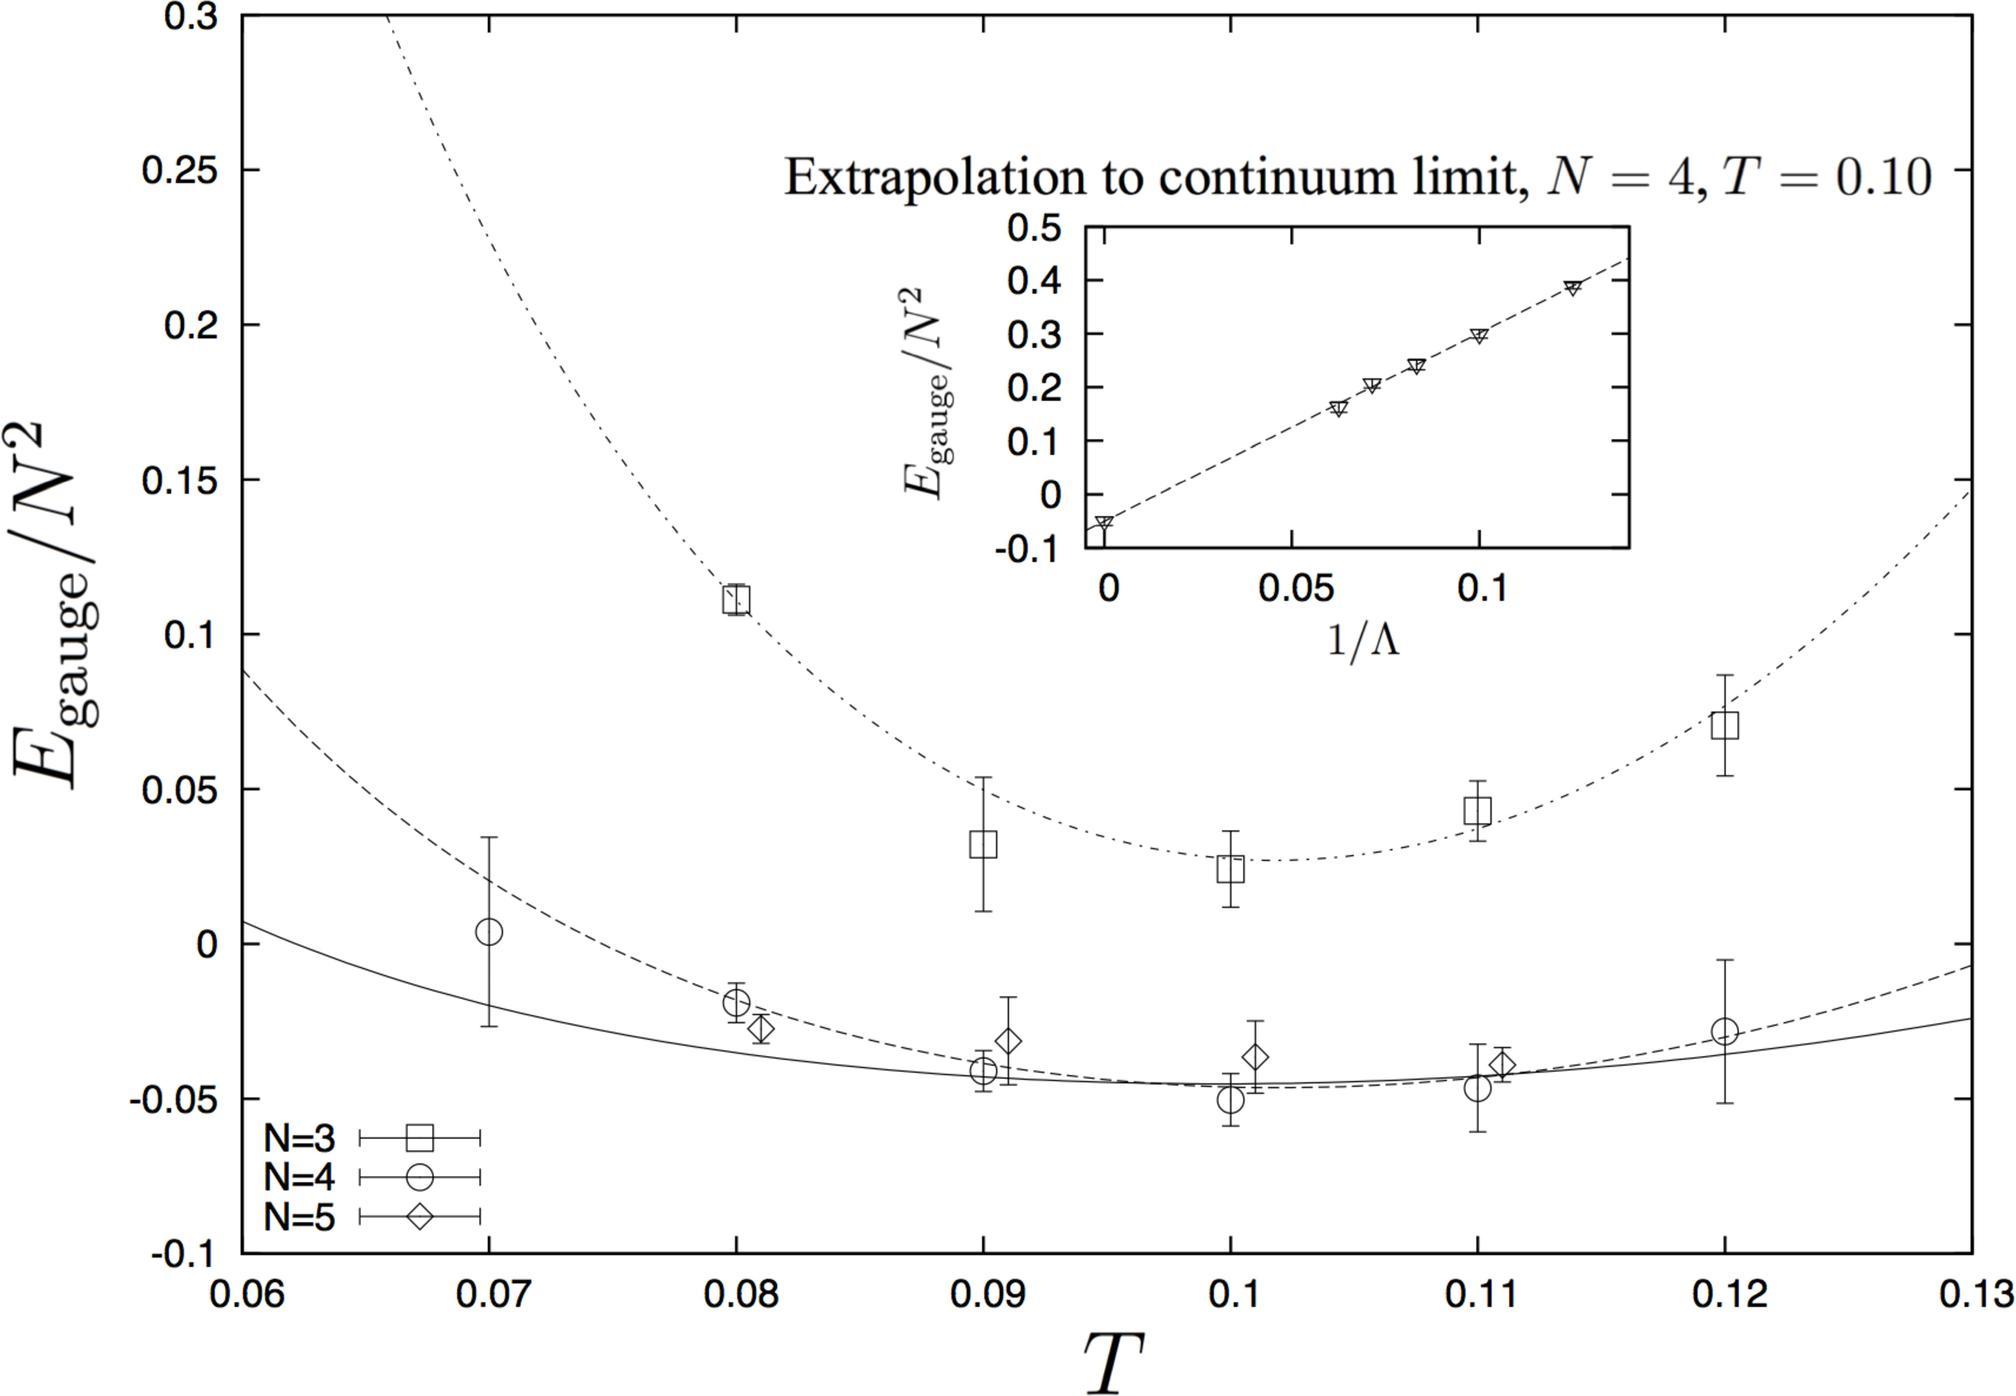Can you explain the significance of the different symbols used in the main graph? Certainly! The main graph utilizes distinct symbols to represent data from different gauge groups, corresponding to different N values. The squares are for N=3, circles for N=4, and diamonds for N=5. These symbols help in comparing how the gauge energy varies with temperature for each group, providing a clear visual differentiation for the reader. 